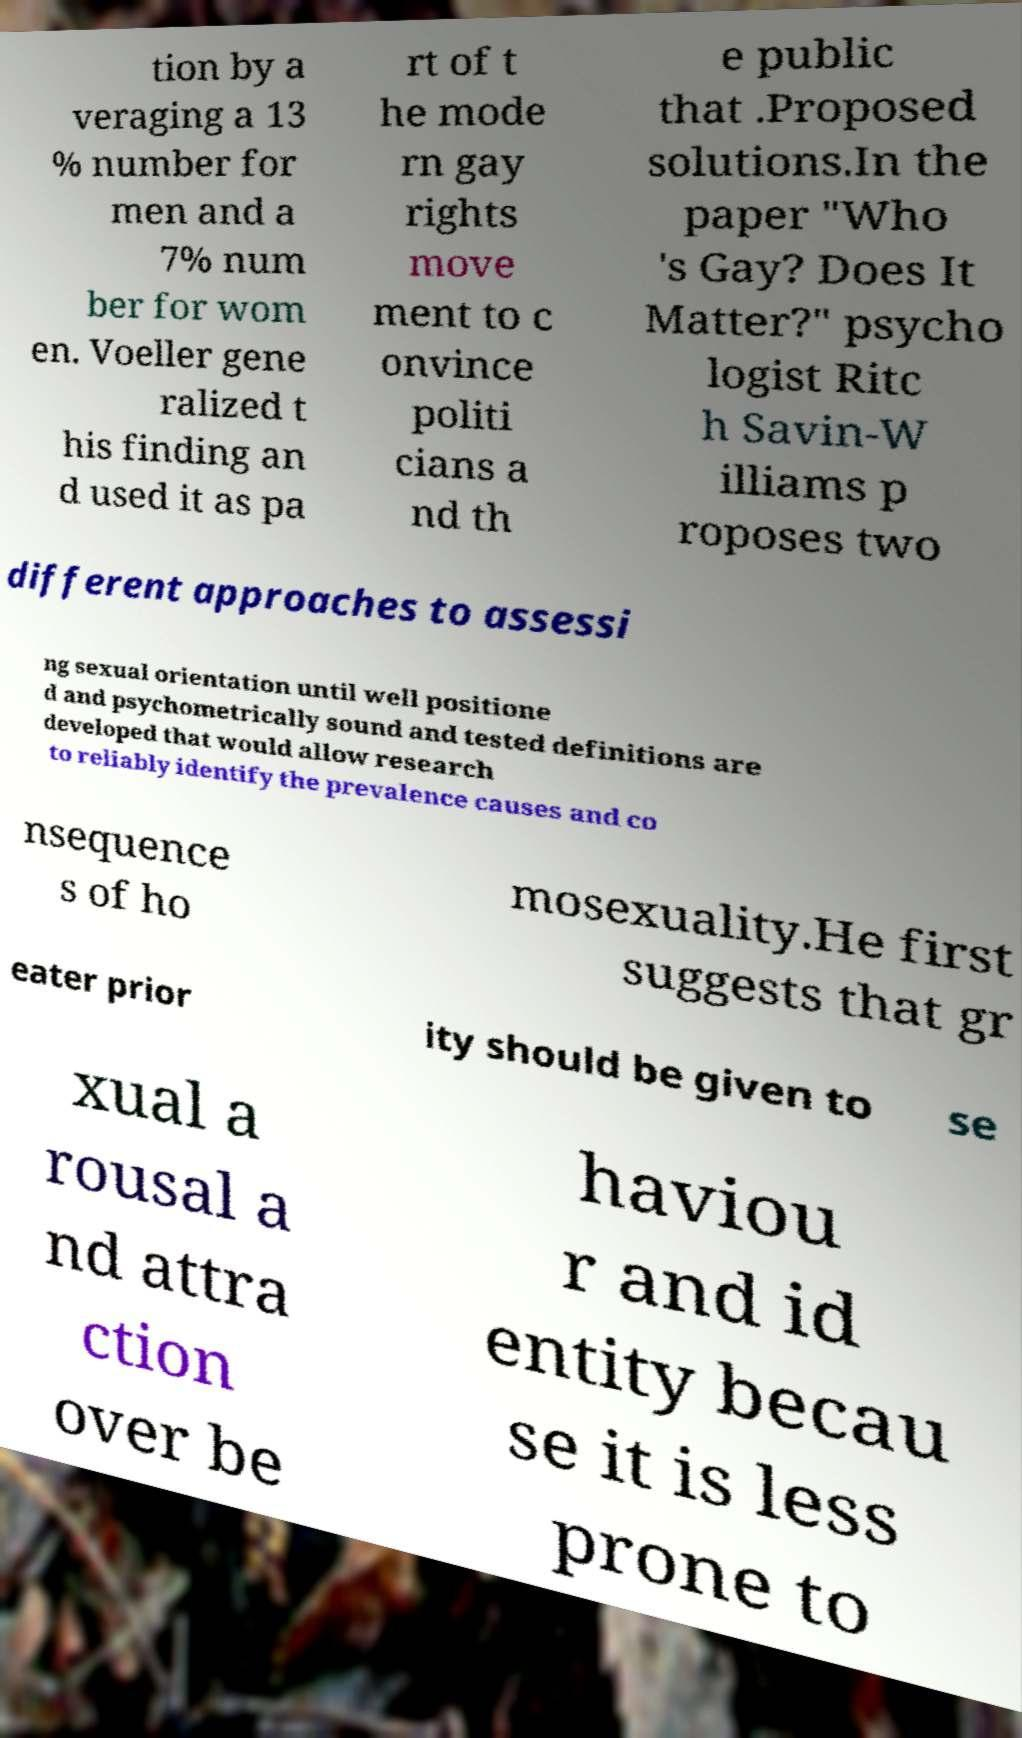I need the written content from this picture converted into text. Can you do that? tion by a veraging a 13 % number for men and a 7% num ber for wom en. Voeller gene ralized t his finding an d used it as pa rt of t he mode rn gay rights move ment to c onvince politi cians a nd th e public that .Proposed solutions.In the paper "Who 's Gay? Does It Matter?" psycho logist Ritc h Savin-W illiams p roposes two different approaches to assessi ng sexual orientation until well positione d and psychometrically sound and tested definitions are developed that would allow research to reliably identify the prevalence causes and co nsequence s of ho mosexuality.He first suggests that gr eater prior ity should be given to se xual a rousal a nd attra ction over be haviou r and id entity becau se it is less prone to 